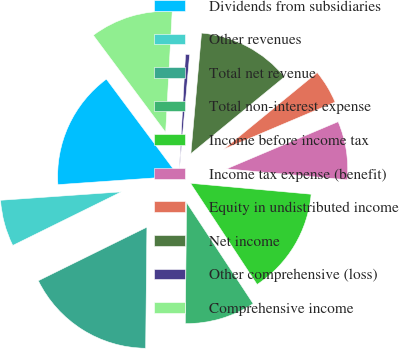Convert chart. <chart><loc_0><loc_0><loc_500><loc_500><pie_chart><fcel>Dividends from subsidiaries<fcel>Other revenues<fcel>Total net revenue<fcel>Total non-interest expense<fcel>Income before income tax<fcel>Income tax expense (benefit)<fcel>Equity in undistributed income<fcel>Net income<fcel>Other comprehensive (loss)<fcel>Comprehensive income<nl><fcel>15.92%<fcel>6.19%<fcel>17.54%<fcel>9.43%<fcel>14.3%<fcel>7.81%<fcel>4.56%<fcel>12.67%<fcel>0.54%<fcel>11.05%<nl></chart> 